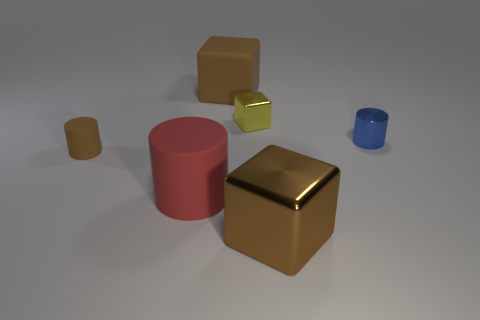Add 1 small brown matte blocks. How many objects exist? 7 Add 1 tiny red objects. How many tiny red objects exist? 1 Subtract 0 red cubes. How many objects are left? 6 Subtract all large cyan metal cylinders. Subtract all rubber objects. How many objects are left? 3 Add 3 large matte things. How many large matte things are left? 5 